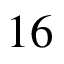<formula> <loc_0><loc_0><loc_500><loc_500>1 6</formula> 